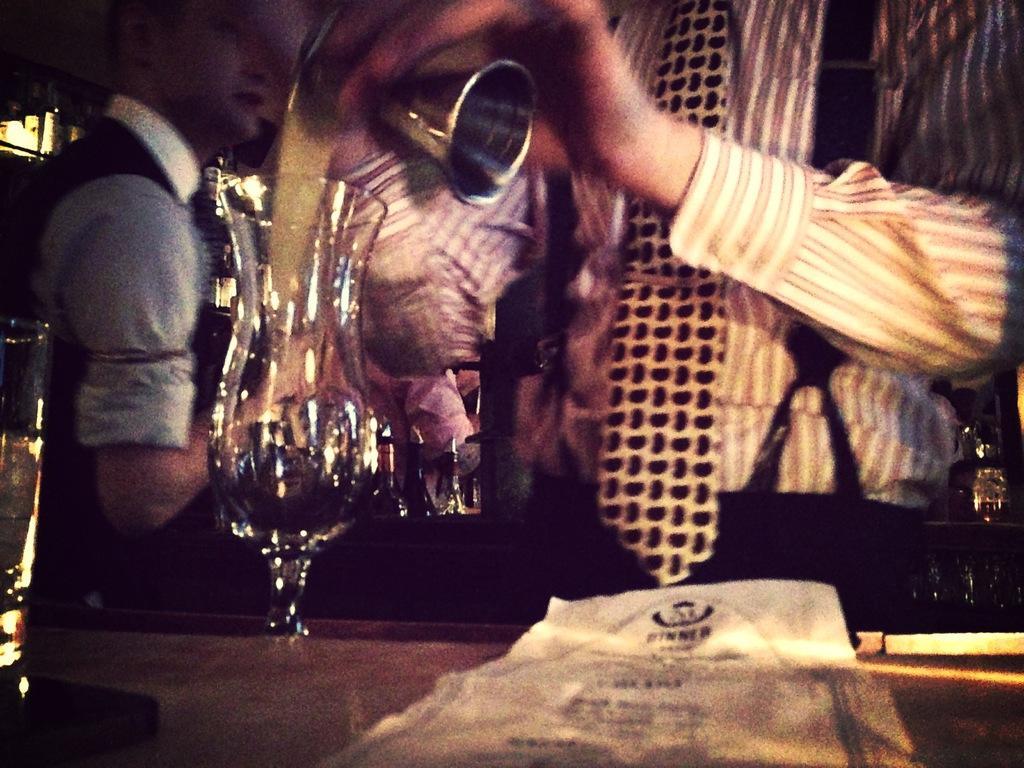Can you describe this image briefly? In this picture, there is a man towards the right and he is pouring liquid in the glass which is on the table. Towards the left, there is another man. 